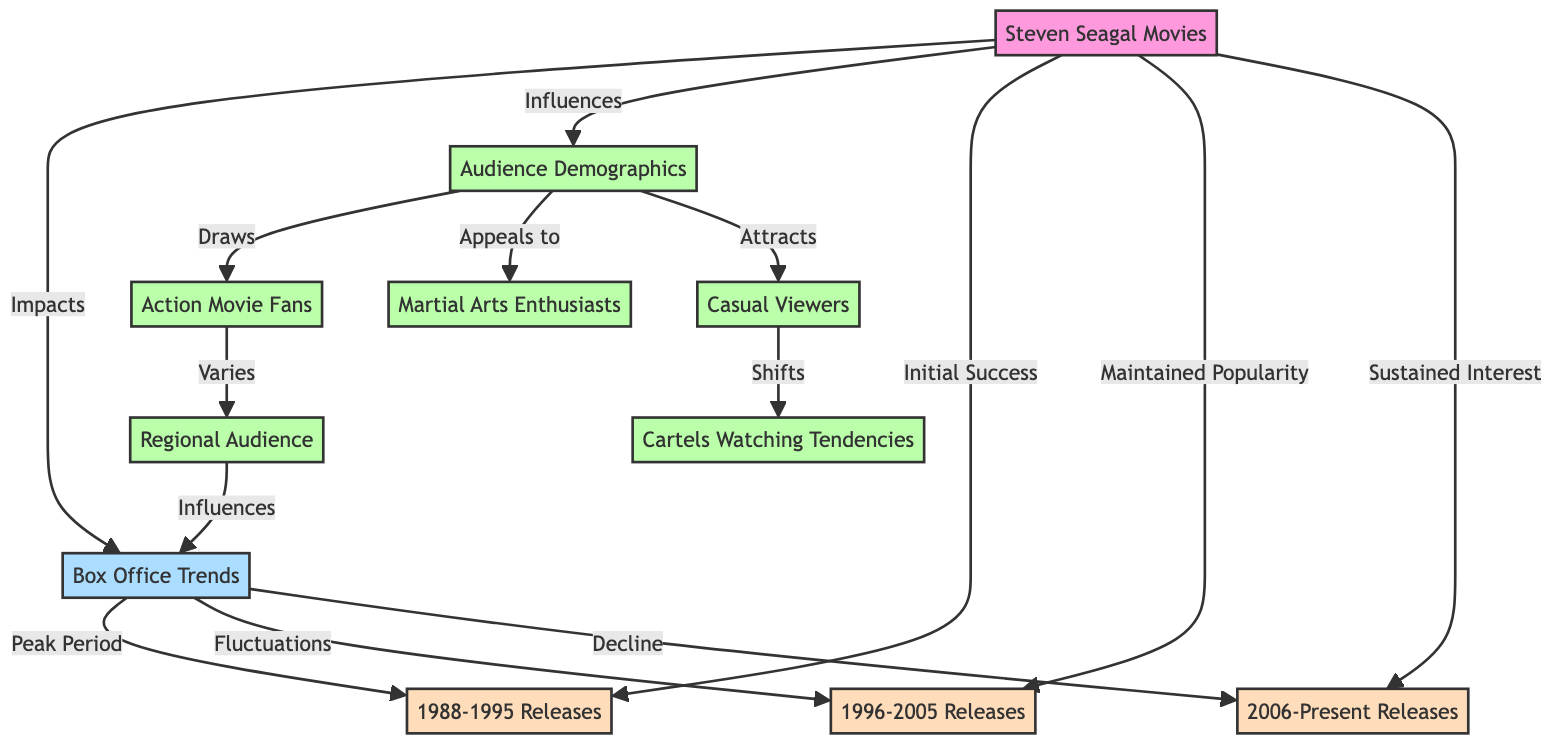What is the primary influence of Steven Seagal Movies? The diagram indicates that Steven Seagal Movies primarily influence Audience Demographics. This can be observed by following the edge labeled "Influences" directly from Steven Seagal Movies to Audience Demographics.
Answer: Audience Demographics Which release period has the peak box office trends? According to the diagram, the 1988-1995 Releases period is marked as the Peak Period for Box Office Trends, as denoted by the edge labeled "Peak Period" connecting Box Office Trends to Early Release Period.
Answer: 1988-1995 Releases How many audience types are influenced by Audience Demographics? The diagram shows three audience types that are drawn or attracted by Audience Demographics: Action Movie Fans, Martial Arts Enthusiasts, and Casual Viewers. By counting these nodes connected to Audience Demographics, we find that there are three distinct audience types.
Answer: 3 What effect do Casual Viewers have on Cartels Watching Tendencies? The diagram explicitly notes that Casual Viewers "shift" Cartels Watching Tendencies, as indicated by the edge labeled "Shifts" between these two nodes.
Answer: Shifts What is the trend observed in Box Office Trends over the Later Career Period? The diagram specifically states that Box Office Trends have a "Decline" during the Later Career Period, which connects from Box Office Trends to Later Career Period.
Answer: Decline Which audience type varies according to Action Movie Fans? The diagram indicates that the audience type which varies according to Action Movie Fans is the Regional Audience, as specified by the edge labeled "Varies" leading to the Regional Audience node.
Answer: Regional Audience How do Steven Seagal Movies correlate with the fluctuations in Box Office Trends? The connection between Steven Seagal Movies and Box Office Trends shows that there are fluctuations tied to the Middle Career Period, illustrated through the edge labeled "Fluctuations" linking Box Office Trends to Middle Career Period. This indicates that while there are peaks and declines, fluctuations also exist, specifically during this period.
Answer: Fluctuations What demographic is primarily attracted by Steven Seagal Movies? The diagram shows that Audience Demographics is influenced by Steven Seagal Movies, which directly attracts Casual Viewers as indicated by the edge labeled "Attracts" linking Audience Demographics to Casual Viewers.
Answer: Casual Viewers 